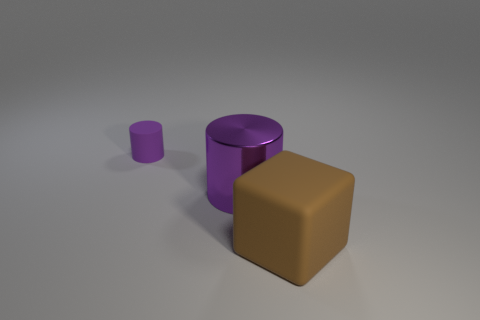Is there any indication of the light source in the image? The shadows of the objects suggest that the light source is coming from the upper left side of the image, as the shadows fall towards the bottom right. What can you say about the arrangement of the objects? The objects are arranged in a way that forms a diagonal line from the lower left to the upper right of the image, with clear space between them, which suggests an intentional composition for visual balance. 